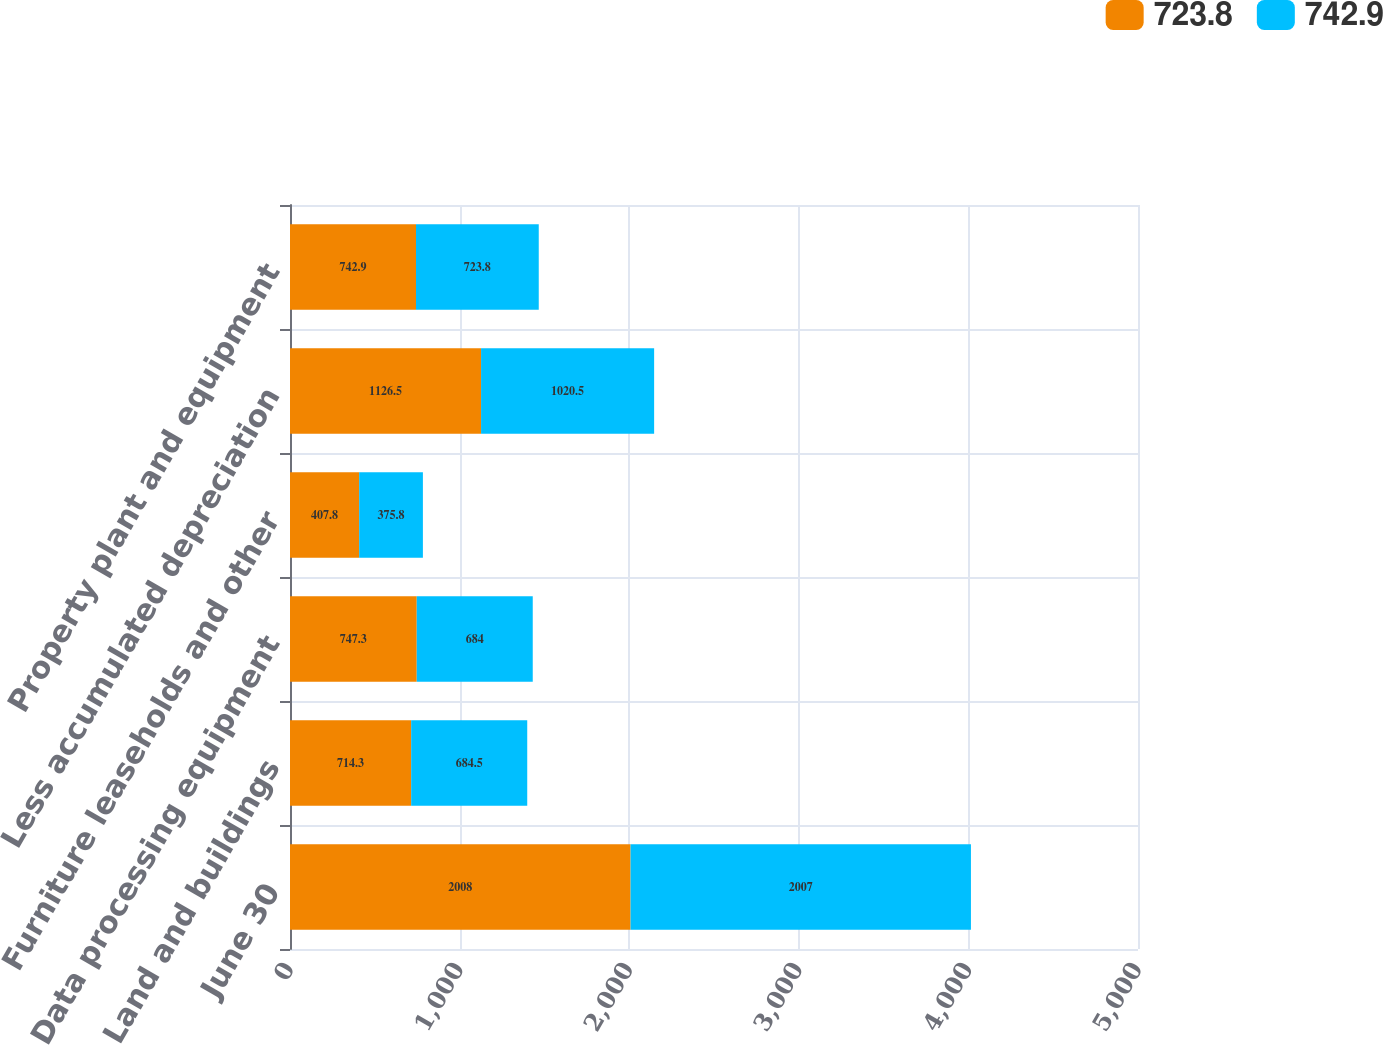Convert chart. <chart><loc_0><loc_0><loc_500><loc_500><stacked_bar_chart><ecel><fcel>June 30<fcel>Land and buildings<fcel>Data processing equipment<fcel>Furniture leaseholds and other<fcel>Less accumulated depreciation<fcel>Property plant and equipment<nl><fcel>723.8<fcel>2008<fcel>714.3<fcel>747.3<fcel>407.8<fcel>1126.5<fcel>742.9<nl><fcel>742.9<fcel>2007<fcel>684.5<fcel>684<fcel>375.8<fcel>1020.5<fcel>723.8<nl></chart> 